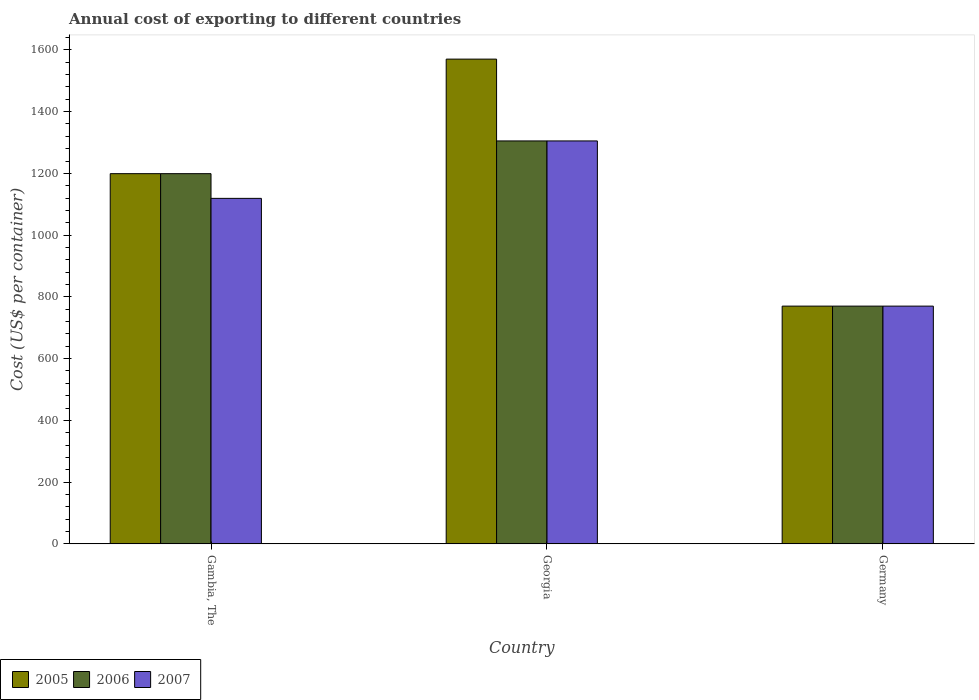How many different coloured bars are there?
Offer a very short reply. 3. Are the number of bars per tick equal to the number of legend labels?
Your answer should be very brief. Yes. How many bars are there on the 3rd tick from the right?
Make the answer very short. 3. What is the total annual cost of exporting in 2007 in Germany?
Offer a terse response. 770. Across all countries, what is the maximum total annual cost of exporting in 2006?
Provide a short and direct response. 1305. Across all countries, what is the minimum total annual cost of exporting in 2006?
Your answer should be very brief. 770. In which country was the total annual cost of exporting in 2006 maximum?
Your answer should be very brief. Georgia. In which country was the total annual cost of exporting in 2006 minimum?
Offer a very short reply. Germany. What is the total total annual cost of exporting in 2006 in the graph?
Provide a short and direct response. 3274. What is the difference between the total annual cost of exporting in 2006 in Georgia and that in Germany?
Your response must be concise. 535. What is the difference between the total annual cost of exporting in 2005 in Germany and the total annual cost of exporting in 2006 in Gambia, The?
Make the answer very short. -429. What is the average total annual cost of exporting in 2005 per country?
Provide a short and direct response. 1179.67. What is the difference between the total annual cost of exporting of/in 2005 and total annual cost of exporting of/in 2007 in Georgia?
Offer a very short reply. 265. What is the ratio of the total annual cost of exporting in 2006 in Georgia to that in Germany?
Your answer should be compact. 1.69. What is the difference between the highest and the second highest total annual cost of exporting in 2005?
Your response must be concise. 800. What is the difference between the highest and the lowest total annual cost of exporting in 2005?
Your answer should be compact. 800. What does the 1st bar from the left in Gambia, The represents?
Make the answer very short. 2005. What does the 2nd bar from the right in Gambia, The represents?
Offer a terse response. 2006. Is it the case that in every country, the sum of the total annual cost of exporting in 2007 and total annual cost of exporting in 2006 is greater than the total annual cost of exporting in 2005?
Your response must be concise. Yes. How many bars are there?
Make the answer very short. 9. How many countries are there in the graph?
Keep it short and to the point. 3. What is the difference between two consecutive major ticks on the Y-axis?
Make the answer very short. 200. How many legend labels are there?
Offer a very short reply. 3. What is the title of the graph?
Ensure brevity in your answer.  Annual cost of exporting to different countries. Does "1998" appear as one of the legend labels in the graph?
Provide a succinct answer. No. What is the label or title of the Y-axis?
Keep it short and to the point. Cost (US$ per container). What is the Cost (US$ per container) in 2005 in Gambia, The?
Offer a very short reply. 1199. What is the Cost (US$ per container) of 2006 in Gambia, The?
Ensure brevity in your answer.  1199. What is the Cost (US$ per container) in 2007 in Gambia, The?
Ensure brevity in your answer.  1119. What is the Cost (US$ per container) in 2005 in Georgia?
Your response must be concise. 1570. What is the Cost (US$ per container) in 2006 in Georgia?
Give a very brief answer. 1305. What is the Cost (US$ per container) in 2007 in Georgia?
Keep it short and to the point. 1305. What is the Cost (US$ per container) of 2005 in Germany?
Provide a succinct answer. 770. What is the Cost (US$ per container) in 2006 in Germany?
Your response must be concise. 770. What is the Cost (US$ per container) of 2007 in Germany?
Offer a very short reply. 770. Across all countries, what is the maximum Cost (US$ per container) of 2005?
Ensure brevity in your answer.  1570. Across all countries, what is the maximum Cost (US$ per container) of 2006?
Keep it short and to the point. 1305. Across all countries, what is the maximum Cost (US$ per container) of 2007?
Provide a succinct answer. 1305. Across all countries, what is the minimum Cost (US$ per container) of 2005?
Offer a terse response. 770. Across all countries, what is the minimum Cost (US$ per container) in 2006?
Provide a short and direct response. 770. Across all countries, what is the minimum Cost (US$ per container) in 2007?
Provide a succinct answer. 770. What is the total Cost (US$ per container) of 2005 in the graph?
Provide a succinct answer. 3539. What is the total Cost (US$ per container) of 2006 in the graph?
Offer a terse response. 3274. What is the total Cost (US$ per container) of 2007 in the graph?
Offer a terse response. 3194. What is the difference between the Cost (US$ per container) in 2005 in Gambia, The and that in Georgia?
Keep it short and to the point. -371. What is the difference between the Cost (US$ per container) of 2006 in Gambia, The and that in Georgia?
Make the answer very short. -106. What is the difference between the Cost (US$ per container) of 2007 in Gambia, The and that in Georgia?
Keep it short and to the point. -186. What is the difference between the Cost (US$ per container) of 2005 in Gambia, The and that in Germany?
Keep it short and to the point. 429. What is the difference between the Cost (US$ per container) of 2006 in Gambia, The and that in Germany?
Offer a terse response. 429. What is the difference between the Cost (US$ per container) in 2007 in Gambia, The and that in Germany?
Your response must be concise. 349. What is the difference between the Cost (US$ per container) of 2005 in Georgia and that in Germany?
Offer a terse response. 800. What is the difference between the Cost (US$ per container) in 2006 in Georgia and that in Germany?
Your answer should be very brief. 535. What is the difference between the Cost (US$ per container) of 2007 in Georgia and that in Germany?
Keep it short and to the point. 535. What is the difference between the Cost (US$ per container) of 2005 in Gambia, The and the Cost (US$ per container) of 2006 in Georgia?
Make the answer very short. -106. What is the difference between the Cost (US$ per container) of 2005 in Gambia, The and the Cost (US$ per container) of 2007 in Georgia?
Provide a succinct answer. -106. What is the difference between the Cost (US$ per container) of 2006 in Gambia, The and the Cost (US$ per container) of 2007 in Georgia?
Offer a terse response. -106. What is the difference between the Cost (US$ per container) in 2005 in Gambia, The and the Cost (US$ per container) in 2006 in Germany?
Your answer should be compact. 429. What is the difference between the Cost (US$ per container) in 2005 in Gambia, The and the Cost (US$ per container) in 2007 in Germany?
Make the answer very short. 429. What is the difference between the Cost (US$ per container) of 2006 in Gambia, The and the Cost (US$ per container) of 2007 in Germany?
Provide a succinct answer. 429. What is the difference between the Cost (US$ per container) of 2005 in Georgia and the Cost (US$ per container) of 2006 in Germany?
Give a very brief answer. 800. What is the difference between the Cost (US$ per container) of 2005 in Georgia and the Cost (US$ per container) of 2007 in Germany?
Keep it short and to the point. 800. What is the difference between the Cost (US$ per container) in 2006 in Georgia and the Cost (US$ per container) in 2007 in Germany?
Offer a terse response. 535. What is the average Cost (US$ per container) in 2005 per country?
Your response must be concise. 1179.67. What is the average Cost (US$ per container) of 2006 per country?
Make the answer very short. 1091.33. What is the average Cost (US$ per container) of 2007 per country?
Offer a very short reply. 1064.67. What is the difference between the Cost (US$ per container) in 2006 and Cost (US$ per container) in 2007 in Gambia, The?
Ensure brevity in your answer.  80. What is the difference between the Cost (US$ per container) in 2005 and Cost (US$ per container) in 2006 in Georgia?
Your response must be concise. 265. What is the difference between the Cost (US$ per container) of 2005 and Cost (US$ per container) of 2007 in Georgia?
Ensure brevity in your answer.  265. What is the difference between the Cost (US$ per container) of 2006 and Cost (US$ per container) of 2007 in Georgia?
Your answer should be compact. 0. What is the difference between the Cost (US$ per container) of 2005 and Cost (US$ per container) of 2006 in Germany?
Your answer should be compact. 0. What is the difference between the Cost (US$ per container) of 2005 and Cost (US$ per container) of 2007 in Germany?
Offer a very short reply. 0. What is the difference between the Cost (US$ per container) of 2006 and Cost (US$ per container) of 2007 in Germany?
Your answer should be compact. 0. What is the ratio of the Cost (US$ per container) of 2005 in Gambia, The to that in Georgia?
Your answer should be compact. 0.76. What is the ratio of the Cost (US$ per container) of 2006 in Gambia, The to that in Georgia?
Your answer should be compact. 0.92. What is the ratio of the Cost (US$ per container) in 2007 in Gambia, The to that in Georgia?
Offer a very short reply. 0.86. What is the ratio of the Cost (US$ per container) of 2005 in Gambia, The to that in Germany?
Your answer should be compact. 1.56. What is the ratio of the Cost (US$ per container) in 2006 in Gambia, The to that in Germany?
Provide a succinct answer. 1.56. What is the ratio of the Cost (US$ per container) of 2007 in Gambia, The to that in Germany?
Offer a very short reply. 1.45. What is the ratio of the Cost (US$ per container) of 2005 in Georgia to that in Germany?
Provide a short and direct response. 2.04. What is the ratio of the Cost (US$ per container) in 2006 in Georgia to that in Germany?
Keep it short and to the point. 1.69. What is the ratio of the Cost (US$ per container) of 2007 in Georgia to that in Germany?
Provide a succinct answer. 1.69. What is the difference between the highest and the second highest Cost (US$ per container) of 2005?
Give a very brief answer. 371. What is the difference between the highest and the second highest Cost (US$ per container) in 2006?
Offer a very short reply. 106. What is the difference between the highest and the second highest Cost (US$ per container) in 2007?
Provide a short and direct response. 186. What is the difference between the highest and the lowest Cost (US$ per container) in 2005?
Provide a short and direct response. 800. What is the difference between the highest and the lowest Cost (US$ per container) in 2006?
Provide a short and direct response. 535. What is the difference between the highest and the lowest Cost (US$ per container) in 2007?
Keep it short and to the point. 535. 